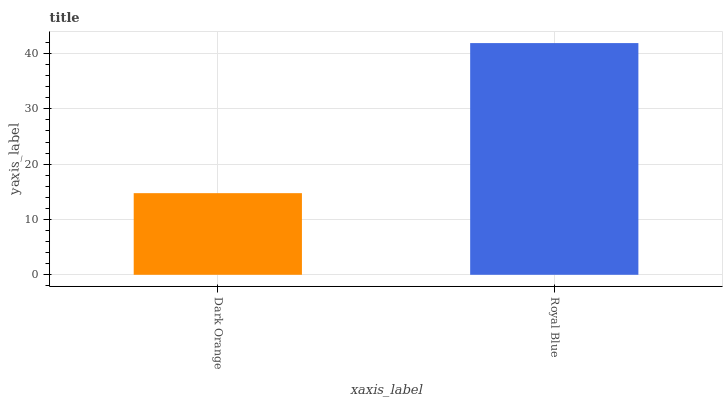Is Dark Orange the minimum?
Answer yes or no. Yes. Is Royal Blue the maximum?
Answer yes or no. Yes. Is Royal Blue the minimum?
Answer yes or no. No. Is Royal Blue greater than Dark Orange?
Answer yes or no. Yes. Is Dark Orange less than Royal Blue?
Answer yes or no. Yes. Is Dark Orange greater than Royal Blue?
Answer yes or no. No. Is Royal Blue less than Dark Orange?
Answer yes or no. No. Is Royal Blue the high median?
Answer yes or no. Yes. Is Dark Orange the low median?
Answer yes or no. Yes. Is Dark Orange the high median?
Answer yes or no. No. Is Royal Blue the low median?
Answer yes or no. No. 